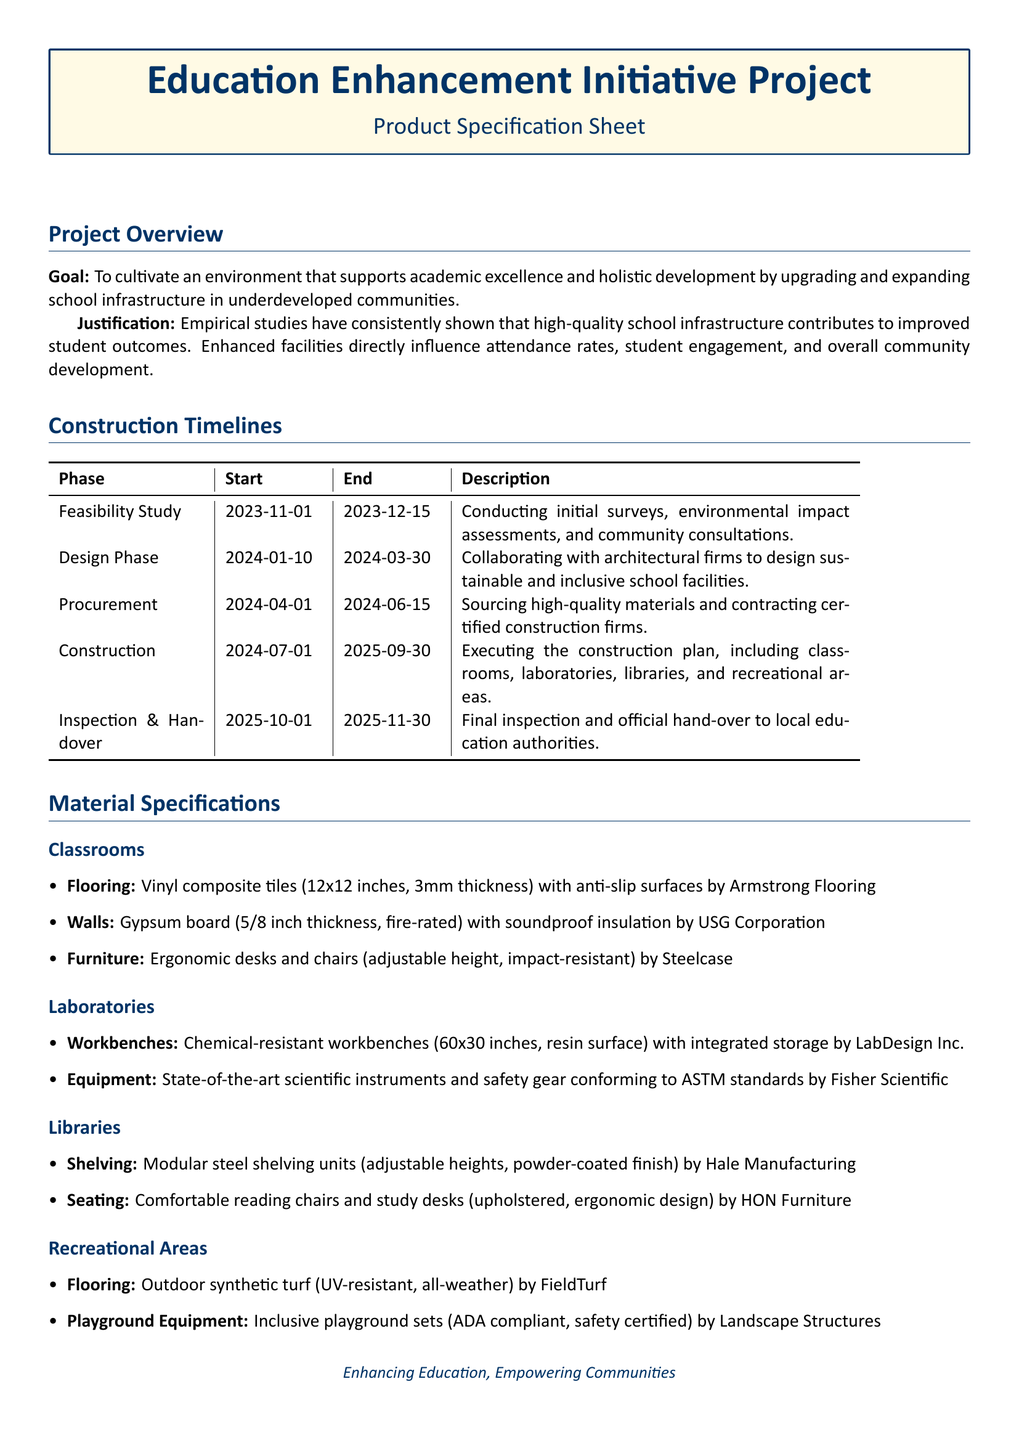What is the goal of the project? The goal of the project is to cultivate an environment that supports academic excellence and holistic development by upgrading and expanding school infrastructure in underdeveloped communities.
Answer: To cultivate an environment that supports academic excellence and holistic development by upgrading and expanding school infrastructure in underdeveloped communities When does the construction phase start? The construction phase starts on July 1, 2024, as indicated in the timeline section of the document.
Answer: July 1, 2024 What type of flooring is specified for the classrooms? The flooring for the classrooms is vinyl composite tiles (12x12 inches, 3mm thickness) with anti-slip surfaces.
Answer: Vinyl composite tiles (12x12 inches, 3mm thickness) with anti-slip surfaces How long is the design phase? The design phase starts on January 10, 2024 and ends on March 30, 2024, making it a duration of 80 days.
Answer: 80 days Which company provides the ergonomic furniture? The ergonomic desks and chairs are provided by Steelcase, as mentioned in the material specifications for classrooms.
Answer: Steelcase What is the end date for the feasibility study? The feasibility study ends on December 15, 2023, as stated in the construction timelines section.
Answer: December 15, 2023 What type of equipment will be used in laboratories? The laboratories will use state-of-the-art scientific instruments and safety gear conforming to ASTM standards.
Answer: State-of-the-art scientific instruments and safety gear conforming to ASTM standards Which firm is responsible for the construction? The document specifies contracting certified construction firms as part of the procurement process, but does not name any specific firm.
Answer: Certified construction firms What kind of flooring is specified for recreational areas? The flooring for recreational areas is outdoor synthetic turf, which is UV-resistant and all-weather.
Answer: Outdoor synthetic turf (UV-resistant, all-weather) 